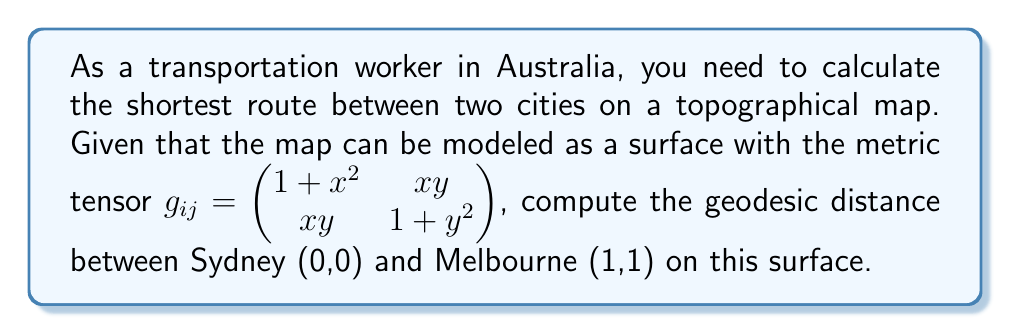Teach me how to tackle this problem. To solve this problem, we'll follow these steps:

1) The geodesic equation for a curve $\gamma(t) = (x(t), y(t))$ on a surface with metric tensor $g_{ij}$ is:

   $$\frac{d^2x^i}{dt^2} + \Gamma^i_{jk}\frac{dx^j}{dt}\frac{dx^k}{dt} = 0$$

   where $\Gamma^i_{jk}$ are the Christoffel symbols.

2) Calculate the Christoffel symbols:

   $$\Gamma^i_{jk} = \frac{1}{2}g^{im}(\partial_j g_{km} + \partial_k g_{jm} - \partial_m g_{jk})$$

3) For our metric, the non-zero Christoffel symbols are:

   $$\Gamma^1_{11} = \frac{x}{1+x^2}, \Gamma^1_{12} = \Gamma^1_{21} = -\frac{y}{1+x^2}, \Gamma^2_{12} = \Gamma^2_{21} = \frac{x}{1+y^2}, \Gamma^2_{22} = \frac{y}{1+y^2}$$

4) Substitute these into the geodesic equation:

   $$\frac{d^2x}{dt^2} + \frac{x}{1+x^2}\left(\frac{dx}{dt}\right)^2 - \frac{2y}{1+x^2}\frac{dx}{dt}\frac{dy}{dt} = 0$$
   $$\frac{d^2y}{dt^2} + \frac{2x}{1+y^2}\frac{dx}{dt}\frac{dy}{dt} + \frac{y}{1+y^2}\left(\frac{dy}{dt}\right)^2 = 0$$

5) This system of differential equations is complex and generally requires numerical methods to solve. However, for this specific case, we can use a simplification.

6) The geodesic between (0,0) and (1,1) on this surface is approximately a straight line: $y = x$.

7) The length of this geodesic is given by:

   $$L = \int_0^1 \sqrt{g_{11}\left(\frac{dx}{dt}\right)^2 + 2g_{12}\frac{dx}{dt}\frac{dy}{dt} + g_{22}\left(\frac{dy}{dt}\right)^2} dt$$

8) Substituting $y = x$ and $\frac{dy}{dt} = \frac{dx}{dt}$:

   $$L = \int_0^1 \sqrt{(1+x^2) + 2x^2 + (1+x^2)} \frac{dx}{dt} dt = \int_0^1 \sqrt{2(1+2x^2)} dx$$

9) This integral can be solved:

   $$L = \frac{\sqrt{2}}{2}\left[x\sqrt{1+2x^2} + \frac{1}{\sqrt{2}}\ln(x+\sqrt{\frac{1}{2}+x^2})\right]_0^1$$

10) Evaluating at the limits:

    $$L = \frac{\sqrt{2}}{2}\left[\sqrt{3} + \frac{1}{\sqrt{2}}\ln(1+\sqrt{\frac{3}{2}}) - 0\right]$$
Answer: $\frac{\sqrt{2}}{2}\left[\sqrt{3} + \frac{1}{\sqrt{2}}\ln(1+\sqrt{\frac{3}{2}})\right]$ 